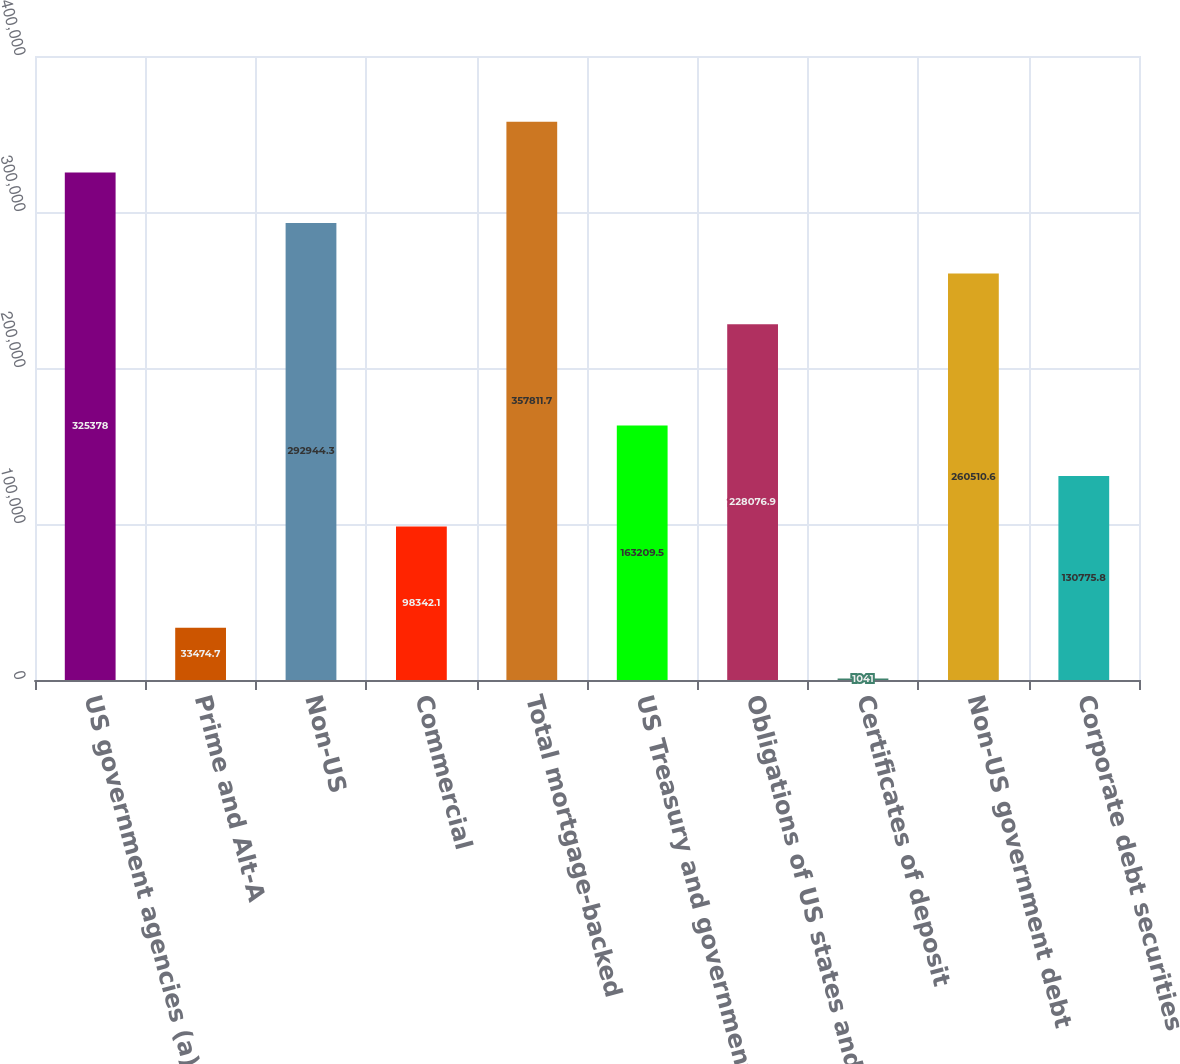<chart> <loc_0><loc_0><loc_500><loc_500><bar_chart><fcel>US government agencies (a)<fcel>Prime and Alt-A<fcel>Non-US<fcel>Commercial<fcel>Total mortgage-backed<fcel>US Treasury and government<fcel>Obligations of US states and<fcel>Certificates of deposit<fcel>Non-US government debt<fcel>Corporate debt securities<nl><fcel>325378<fcel>33474.7<fcel>292944<fcel>98342.1<fcel>357812<fcel>163210<fcel>228077<fcel>1041<fcel>260511<fcel>130776<nl></chart> 